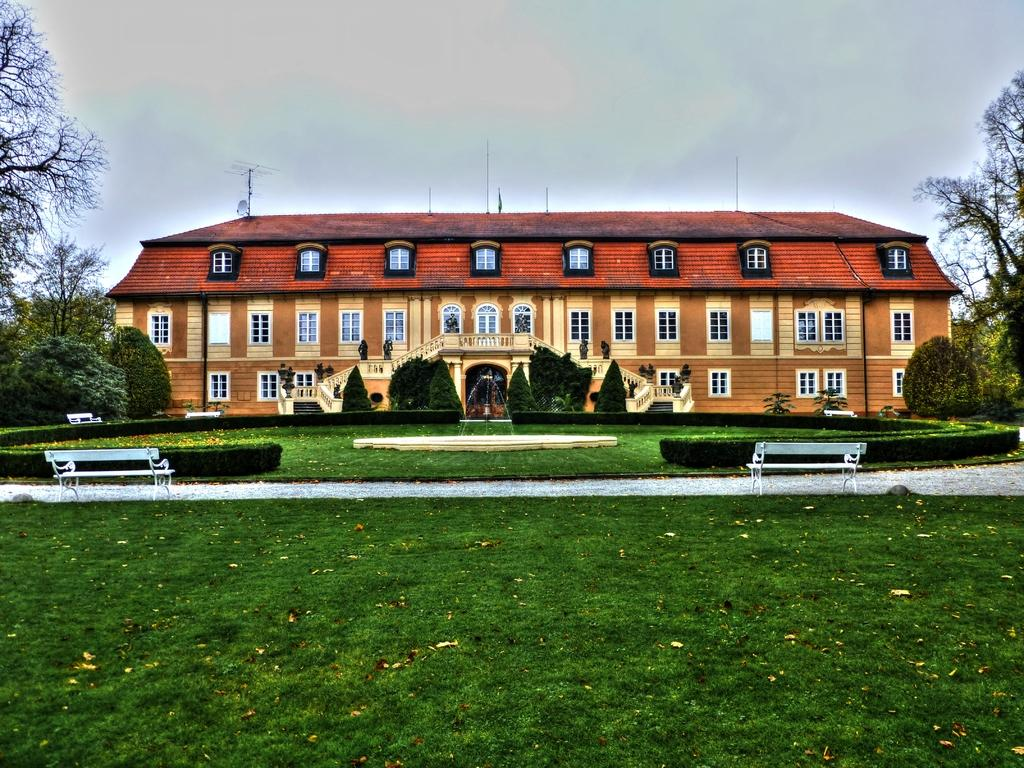What type of structure is visible in the image? There is a building in the image. What is located in front of the building? There is a water fountain in front of the building. What can be seen on the grassland near the building? Trees and plants are present on the grassland. How many benches are visible on the path? There are two benches on the path. What is visible at the top of the image? The sky is visible at the top of the image. What type of cloth is being used for teaching in the image? There is no cloth or teaching activity present in the image. 